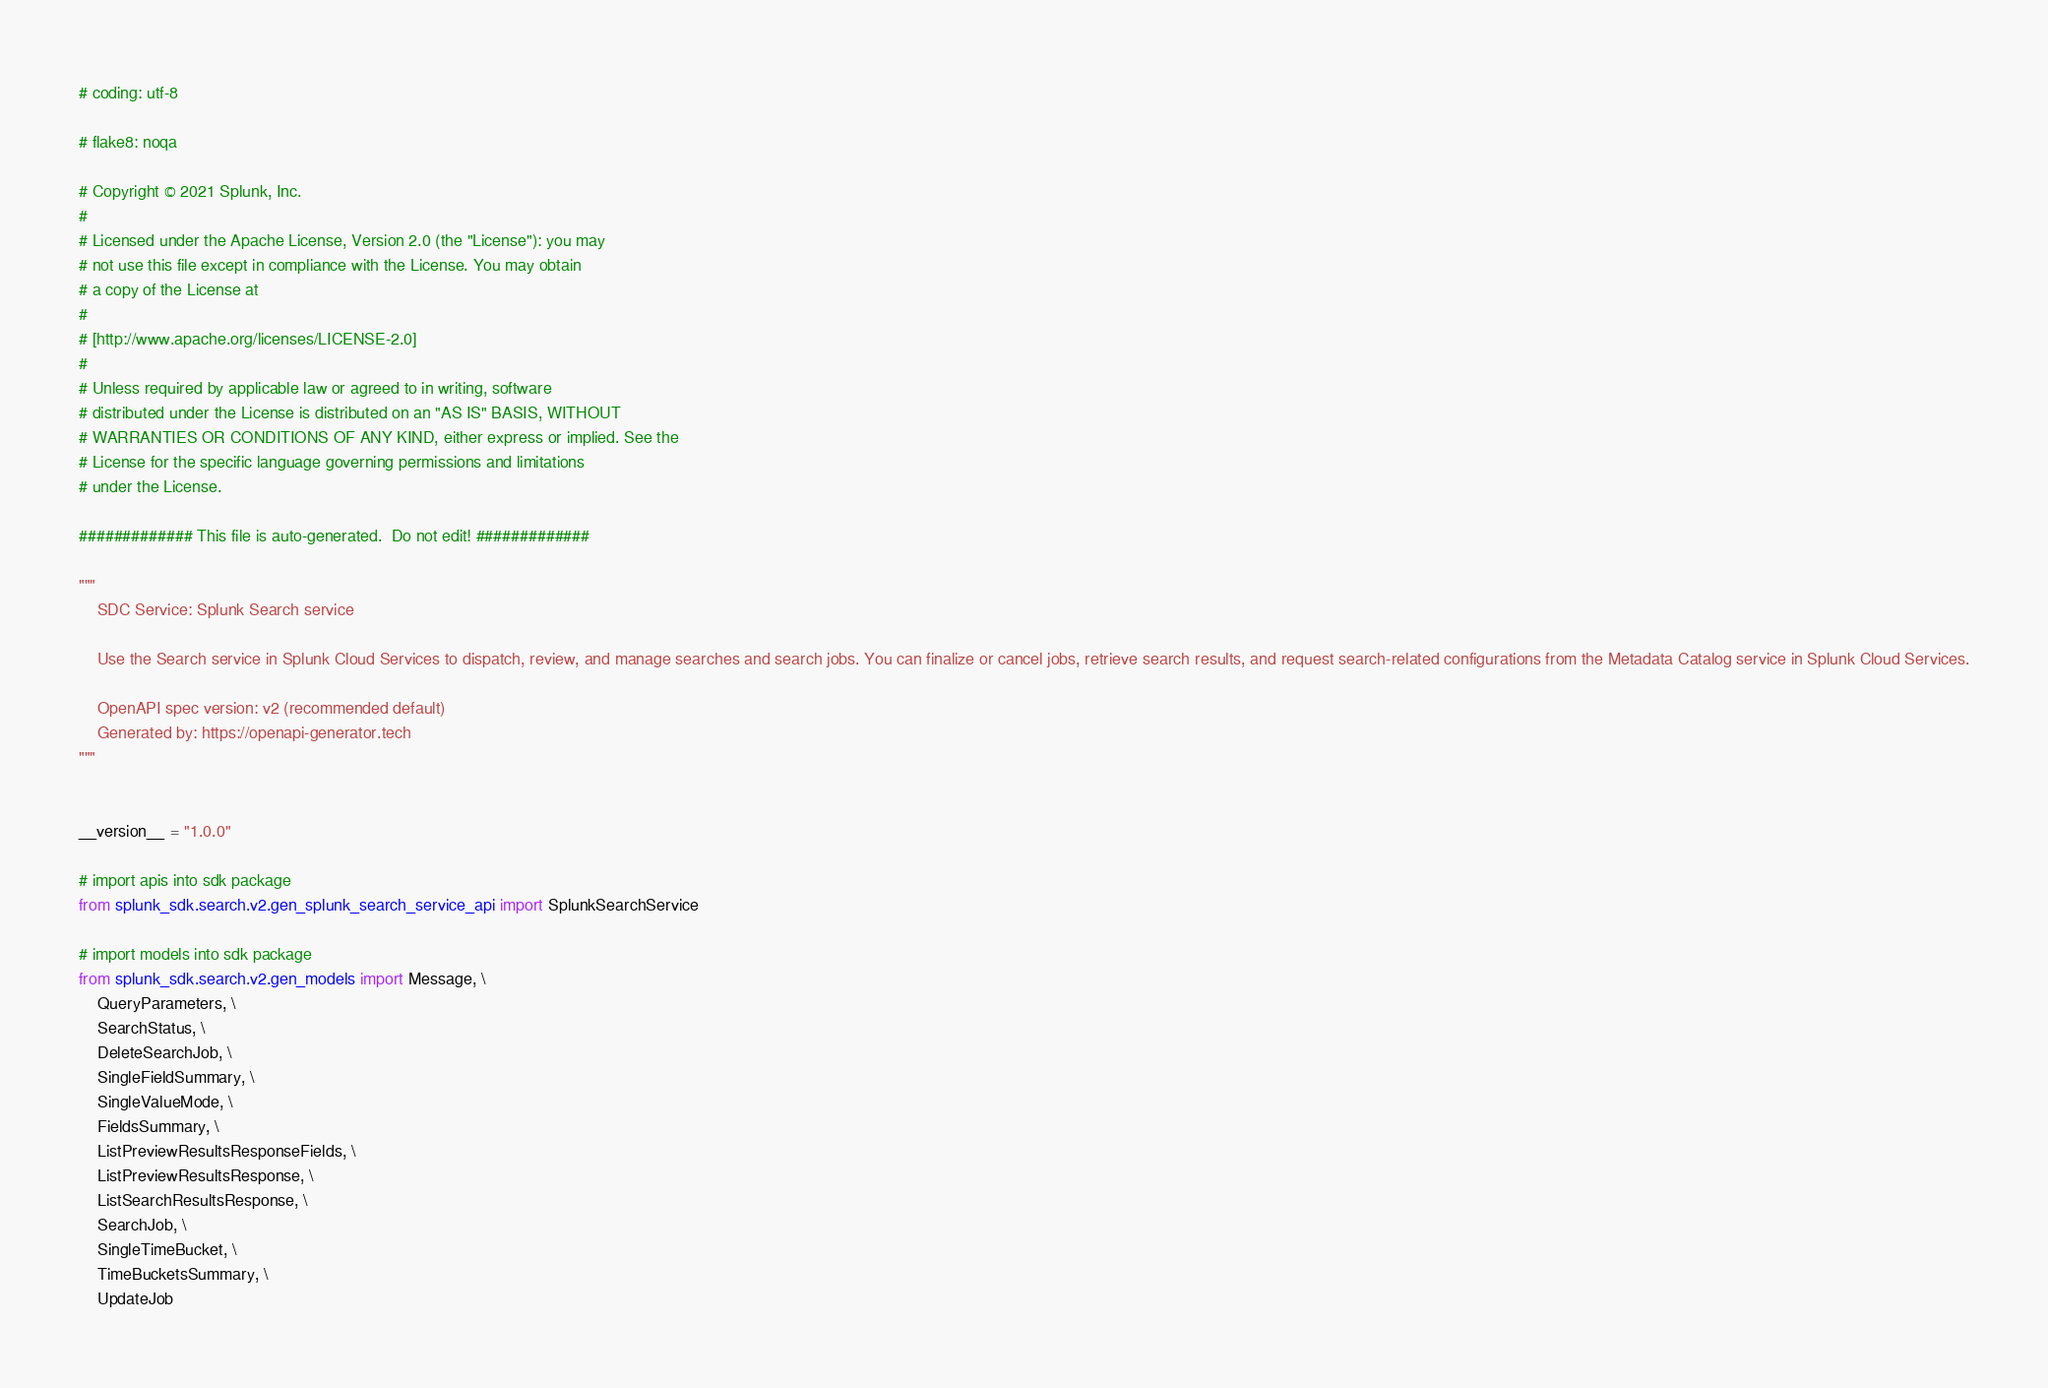Convert code to text. <code><loc_0><loc_0><loc_500><loc_500><_Python_># coding: utf-8

# flake8: noqa

# Copyright © 2021 Splunk, Inc.
#
# Licensed under the Apache License, Version 2.0 (the "License"): you may
# not use this file except in compliance with the License. You may obtain
# a copy of the License at
#
# [http://www.apache.org/licenses/LICENSE-2.0]
#
# Unless required by applicable law or agreed to in writing, software
# distributed under the License is distributed on an "AS IS" BASIS, WITHOUT
# WARRANTIES OR CONDITIONS OF ANY KIND, either express or implied. See the
# License for the specific language governing permissions and limitations
# under the License.

############# This file is auto-generated.  Do not edit! #############

"""
    SDC Service: Splunk Search service

    Use the Search service in Splunk Cloud Services to dispatch, review, and manage searches and search jobs. You can finalize or cancel jobs, retrieve search results, and request search-related configurations from the Metadata Catalog service in Splunk Cloud Services.

    OpenAPI spec version: v2 (recommended default)
    Generated by: https://openapi-generator.tech
"""


__version__ = "1.0.0"

# import apis into sdk package
from splunk_sdk.search.v2.gen_splunk_search_service_api import SplunkSearchService

# import models into sdk package
from splunk_sdk.search.v2.gen_models import Message, \
    QueryParameters, \
    SearchStatus, \
    DeleteSearchJob, \
    SingleFieldSummary, \
    SingleValueMode, \
    FieldsSummary, \
    ListPreviewResultsResponseFields, \
    ListPreviewResultsResponse, \
    ListSearchResultsResponse, \
    SearchJob, \
    SingleTimeBucket, \
    TimeBucketsSummary, \
    UpdateJob
</code> 